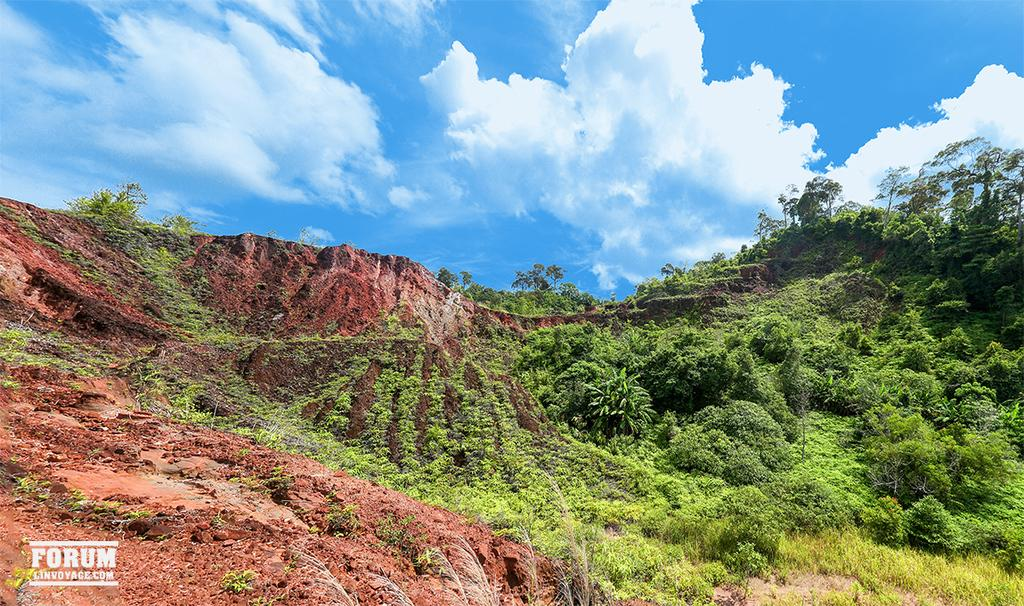What type of vegetation can be seen in the image? There is a group of trees, grass, and plants in the image. Where are the trees, grass, and plants located? They are on hills in the image. What else can be seen in the image besides the vegetation? The sky is visible in the image. How would you describe the sky in the image? The sky looks cloudy in the image. What color is the lead on the ground in the image? There is no lead present in the image; it is a natural landscape with trees, grass, plants, and a cloudy sky. How many toes can be seen on the plants in the image? Plants do not have toes, as they are not living beings with feet. 